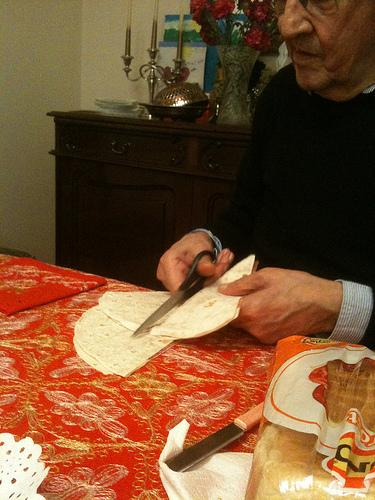Count the number of different items on the table. There are 8 different items on the table. Briefly mention the main objects in the scene and their interactions. The main objects are: man, scissors, tortillas, tablecloth, knife, bread, bread bag, and napkin. The man is using scissors to cut tortillas. What kind of furniture is in the background, and what is its color? There is a piece of dark brown wooden furniture in the background. Identify the object being cut by the man and with what tool. Man is cutting white tortillas using a pair of scissors. Evaluate the image quality based on the clarity of object descriptions. The image quality is good, as all objects are described clearly with distinct colors and details. Identify the item on the table with a wooden handle, and list its material composition. A small knife with a brown wooden handle and a silver blade. What is the pattern on the red napkin and what are its dimensions? The red napkin has an old embroidered design, and its dimensions are Width: 107, Height: 107. Analyze the image sentiment and describe the overall atmosphere. The image sentiment is neutral, depicting an everyday activity with a man cutting tortillas in a casual setting. Provide a description of the tablecloth's color and design. The tablecloth is red with white and gold stitching, featuring a gold and red design. What is the color of the bread bag and which object is it closest to? The bread bag is orange and white, and it is closest to the loaf of bread. Could you point out the cat that is playing with the gold ribbon on the red tablecloth? Describe the cat's fur color and its eye color. The instruction is misleading because there is no mention of a cat in the image. It tricks the listener by associating the cat with two real objects (gold ribbon and red tablecloth) and asking them to describe the cat's appearance. Observe the painting hanging on the wall behind the man - what is the predominant color and theme of the artwork? No, it's not mentioned in the image. Can you find the green apple on the table near the bread? Make sure to note its color and shape. There is no mention of a green apple in the list of objects captured in the image. The instruction creates a false expectation by specifying a non-existent object, color, and location in relation to another object (bread). Do you see a ceramic cup of steaming hot coffee placed right next to the vase with red flowers? Tell me its pattern and how full it is. The instruction is misleading as it introduces a non-existent object (ceramic cup) and associates it with a real object (vase with red flowers). It asks the listener to provide details about the cup's pattern and contents, further confusing them. 